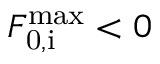<formula> <loc_0><loc_0><loc_500><loc_500>F _ { 0 , i } ^ { \max } < 0</formula> 